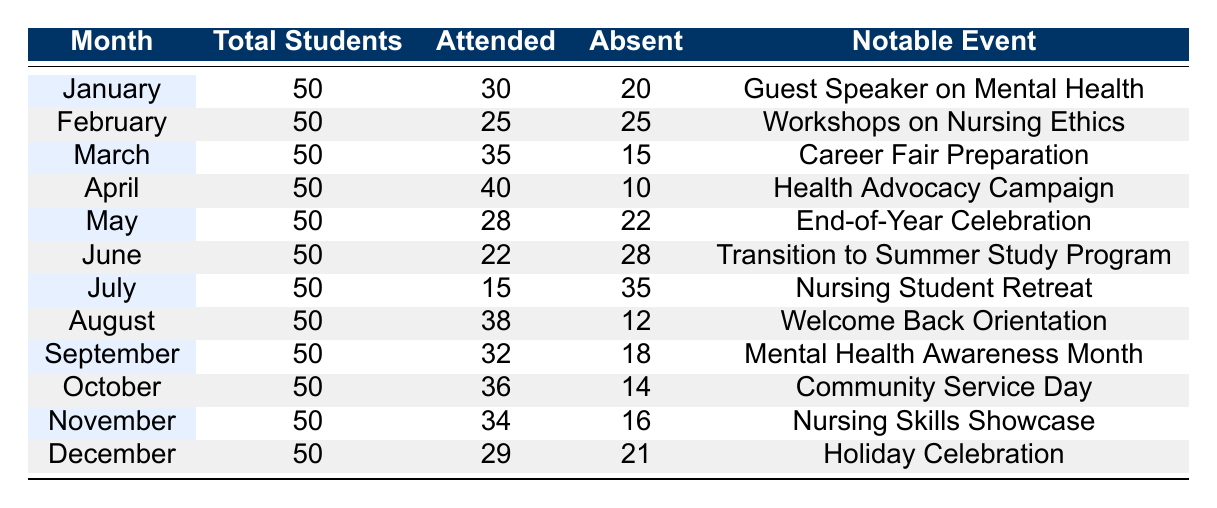What month had the highest attendance of nursing students? By examining the 'Attended' column, we can compare the numbers. January had 30, February had 25, March had 35, April had 40, May had 28, June had 22, July had 15, August had 38, September had 32, October had 36, November had 34, and December had 29. The month with the highest attendance is April with 40 students.
Answer: April How many students were absent in February? Looking at the 'Absent' column, February shows a total of 25 students were absent.
Answer: 25 What event in August contributed to the highest attendance increase? By checking the 'Notable Event' column for August, it lists "Welcome Back Orientation" with an attendance increase of 15, which is the highest increase for that month.
Answer: Welcome Back Orientation What is the total number of students who attended from January to March? We sum the 'Attended' values for January (30), February (25), and March (35). Total = 30 + 25 + 35 = 90.
Answer: 90 Did any month have more absences than attendances? By checking each month's 'Attended' and 'Absent' values, July is the only month with 15 attended and 35 absent, confirming more absences than attendances.
Answer: Yes What is the average attendance for the months of September to December? The attendances for September (32), October (36), November (34), and December (29) sum to 32 + 36 + 34 + 29 = 131. There are 4 months, so the average is 131 / 4 = 32.75.
Answer: 32.75 Which speaker contributed to the lowest attendance increase, and what was it? Reviewing the 'Notable Event’ details, June's event “Transition to Summer Study Program” led to the lowest attendance increase of 3, which is less than any other month.
Answer: Dean Michael Foster, 3 How many months had at least 30 students in attendance? By scanning the 'Attended' column, the months with attendance of at least 30 are January (30), March (35), April (40), August (38), September (32), October (36), and November (34). This gives us 7 months.
Answer: 7 